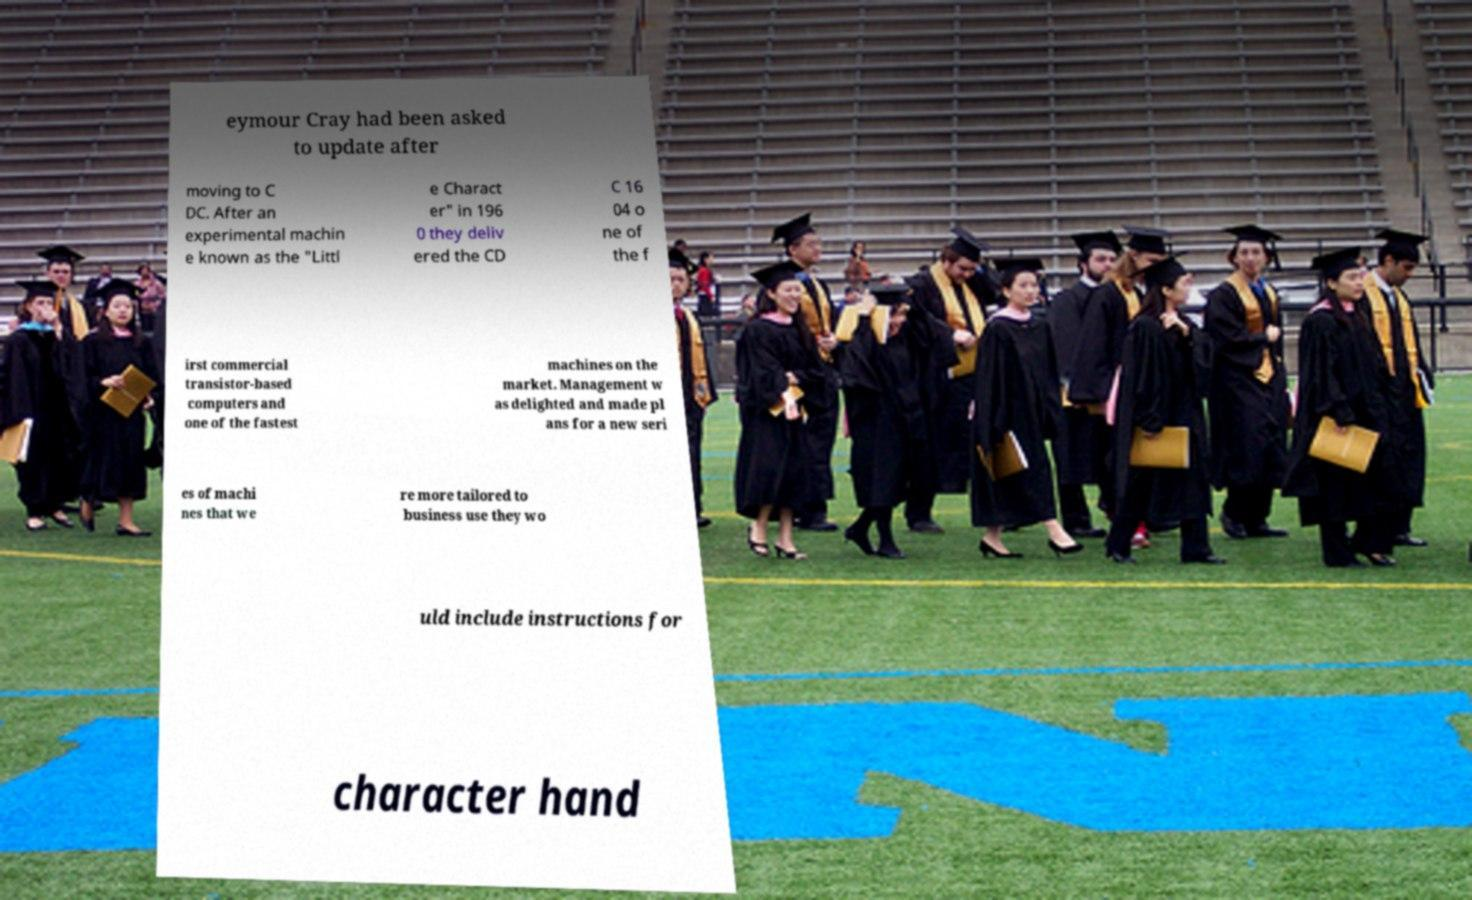I need the written content from this picture converted into text. Can you do that? eymour Cray had been asked to update after moving to C DC. After an experimental machin e known as the "Littl e Charact er" in 196 0 they deliv ered the CD C 16 04 o ne of the f irst commercial transistor-based computers and one of the fastest machines on the market. Management w as delighted and made pl ans for a new seri es of machi nes that we re more tailored to business use they wo uld include instructions for character hand 